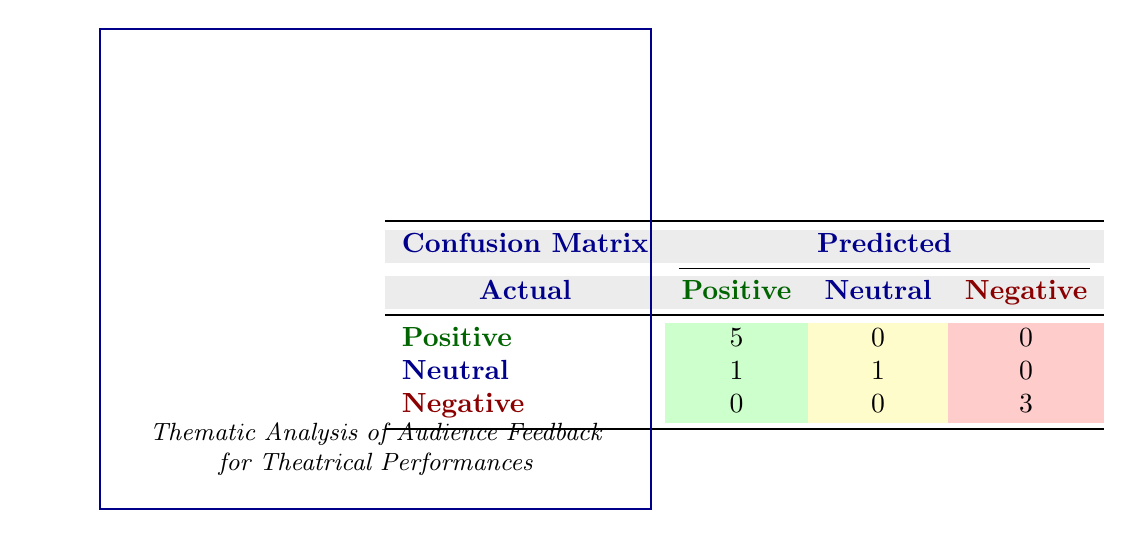What is the total number of positive audience ratings? The table shows 5 ratings in the "Positive" row under the "Positive" column. Therefore, we can directly read the total as 5.
Answer: 5 How many performances received a neutral rating? Looking at the "Neutral" column, there is 1 count in the "Positive" row and 1 count in the "Neutral" row, giving a total of 2 performances (one from "Echoes of Silence" and one from "Beyond the Horizon").
Answer: 2 Are there any performances that received only negative ratings? In the "Negative" row, it shows 3 counts under the "Negative" column, indicating that there are indeed performances that received only negative ratings.
Answer: Yes What percentage of positive ratings were given to "The Last Sunset"? "The Last Sunset" received 1 positive rating, while the total number of positive ratings is 5. To find the percentage, we calculate (1/5) * 100 = 20%.
Answer: 20% What is the total count of negative ratings across all performances? The "Negative" row shows a count of 3 under the "Negative" column, so the total negative ratings across all performances can be retrieved directly from the row total.
Answer: 3 Which performance received the highest number of positive ratings? The table indicates that "Whispers in the Wind" and "The Last Sunset" had a tie, each receiving 1 count of "Positive" ratings, leading to the conclusion that both performances had the same number of positive ratings.
Answer: Whispers in the Wind and The Last Sunset If we combine the neutral and negative ratings for "The Dance of Shadows," what is the total count? "The Dance of Shadows" has 1 count in the "Neutral" row and 1 count in the "Negative" row. Adding these together, we have 1 + 1 = 2.
Answer: 2 What is the difference between the number of positive and negative ratings? Adding all positive ratings gives us a total of 5, and all negative ratings give us a total of 3. The difference is calculated as 5 - 3 = 2.
Answer: 2 Did "Beyond the Horizon" receive more positive ratings than negative ratings? "Beyond the Horizon" has 1 positive rating and 0 negative ratings. Since 1 is greater than 0, we can conclude that it received more positive ratings than negative.
Answer: Yes 